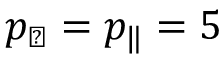Convert formula to latex. <formula><loc_0><loc_0><loc_500><loc_500>p _ { \perp } = p _ { \| } = 5</formula> 